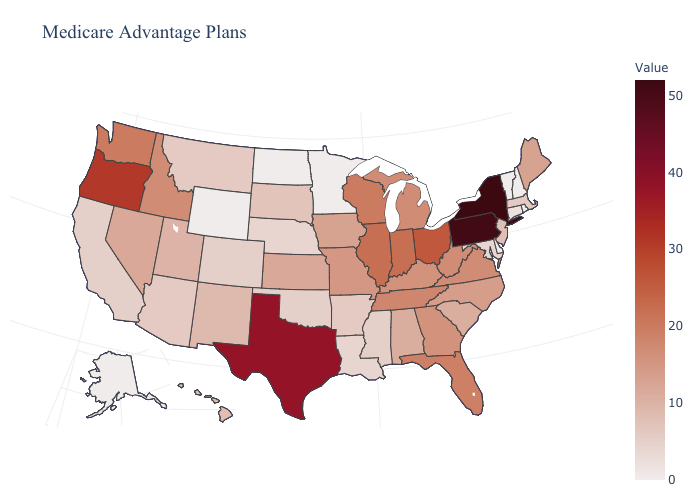Does New York have the highest value in the USA?
Short answer required. Yes. Does Minnesota have the highest value in the MidWest?
Short answer required. No. Does Delaware have the lowest value in the South?
Be succinct. Yes. Among the states that border Florida , which have the highest value?
Concise answer only. Georgia. Which states have the highest value in the USA?
Answer briefly. New York. Among the states that border Wyoming , does Nebraska have the lowest value?
Short answer required. Yes. 